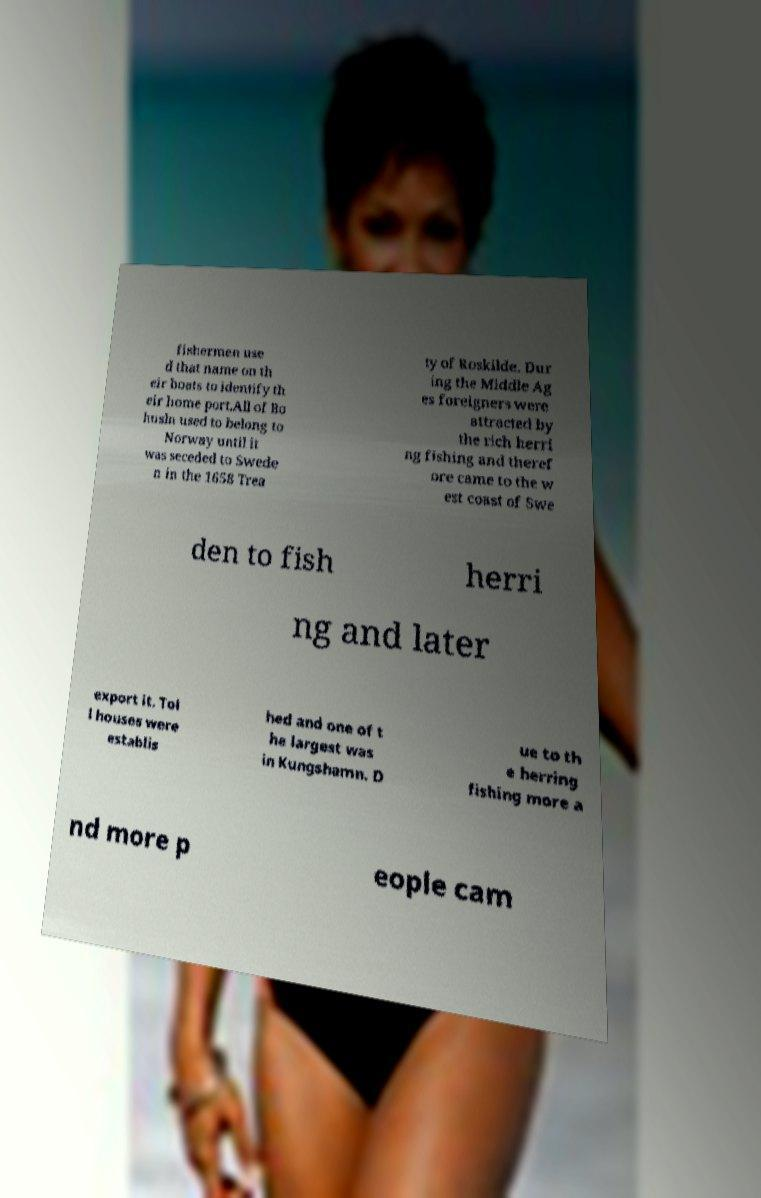Could you assist in decoding the text presented in this image and type it out clearly? fishermen use d that name on th eir boats to identify th eir home port.All of Bo husln used to belong to Norway until it was seceded to Swede n in the 1658 Trea ty of Roskilde. Dur ing the Middle Ag es foreigners were attracted by the rich herri ng fishing and theref ore came to the w est coast of Swe den to fish herri ng and later export it. Tol l houses were establis hed and one of t he largest was in Kungshamn. D ue to th e herring fishing more a nd more p eople cam 